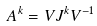<formula> <loc_0><loc_0><loc_500><loc_500>A ^ { k } = V J ^ { k } V ^ { - 1 }</formula> 